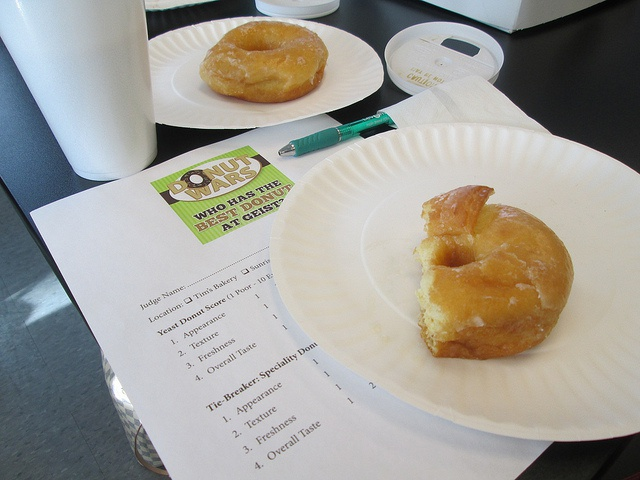Describe the objects in this image and their specific colors. I can see donut in lightblue, olive, and tan tones, cup in lightgray, darkgray, and lightblue tones, dining table in lightblue, black, lightgray, and brown tones, and donut in lightblue, olive, and tan tones in this image. 